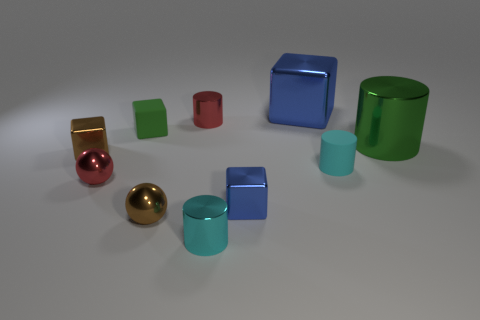What material is the blue block that is the same size as the cyan matte thing?
Offer a very short reply. Metal. What number of metallic objects are either red balls or small cylinders?
Provide a short and direct response. 3. What is the color of the cylinder that is both to the left of the large blue object and in front of the small red metal cylinder?
Offer a very short reply. Cyan. What number of brown metallic things are on the right side of the brown metal block?
Your answer should be very brief. 1. What is the big cylinder made of?
Offer a very short reply. Metal. There is a rubber object that is in front of the tiny brown shiny object that is on the left side of the tiny block behind the large green cylinder; what is its color?
Keep it short and to the point. Cyan. How many cubes have the same size as the green cylinder?
Your response must be concise. 1. What color is the cube that is behind the red cylinder?
Offer a terse response. Blue. How many other objects are there of the same size as the green cylinder?
Ensure brevity in your answer.  1. How big is the metal object that is both behind the small red ball and on the left side of the matte block?
Make the answer very short. Small. 